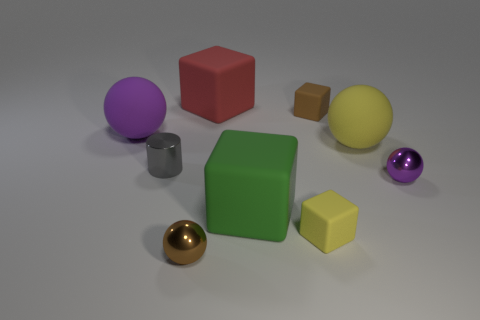How many purple balls must be subtracted to get 1 purple balls? 1 Subtract 1 spheres. How many spheres are left? 3 Subtract all blue cubes. Subtract all blue cylinders. How many cubes are left? 4 Add 1 green things. How many objects exist? 10 Subtract all blocks. How many objects are left? 5 Subtract 0 purple cubes. How many objects are left? 9 Subtract all tiny cyan rubber blocks. Subtract all small cubes. How many objects are left? 7 Add 6 small gray metal objects. How many small gray metal objects are left? 7 Add 6 red matte things. How many red matte things exist? 7 